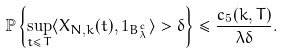<formula> <loc_0><loc_0><loc_500><loc_500>\mathbb { P } \left \{ \sup _ { t \leq T } \langle X _ { N , k } ( t ) , 1 _ { B _ { \lambda } ^ { c } } \rangle > \delta \right \} \leq \frac { c _ { 5 } ( k , T ) } { \lambda \delta } .</formula> 